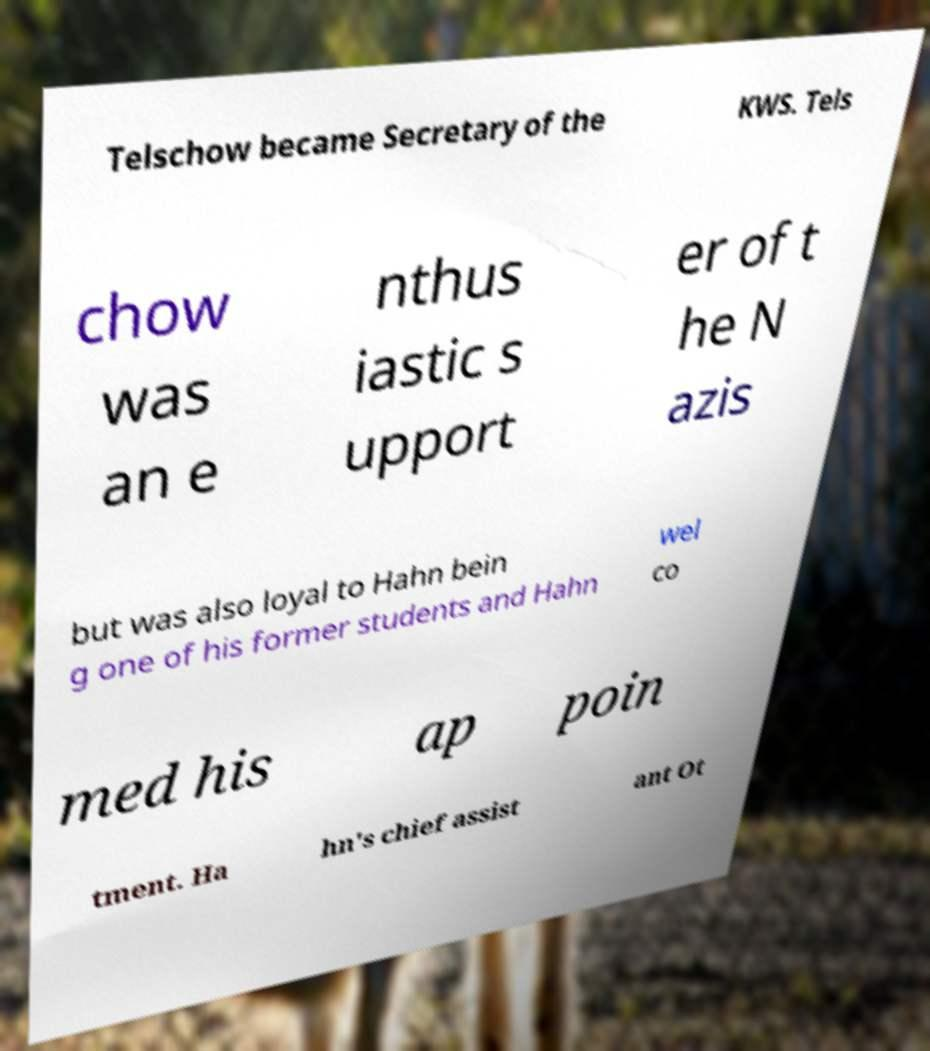Please identify and transcribe the text found in this image. Telschow became Secretary of the KWS. Tels chow was an e nthus iastic s upport er of t he N azis but was also loyal to Hahn bein g one of his former students and Hahn wel co med his ap poin tment. Ha hn's chief assist ant Ot 